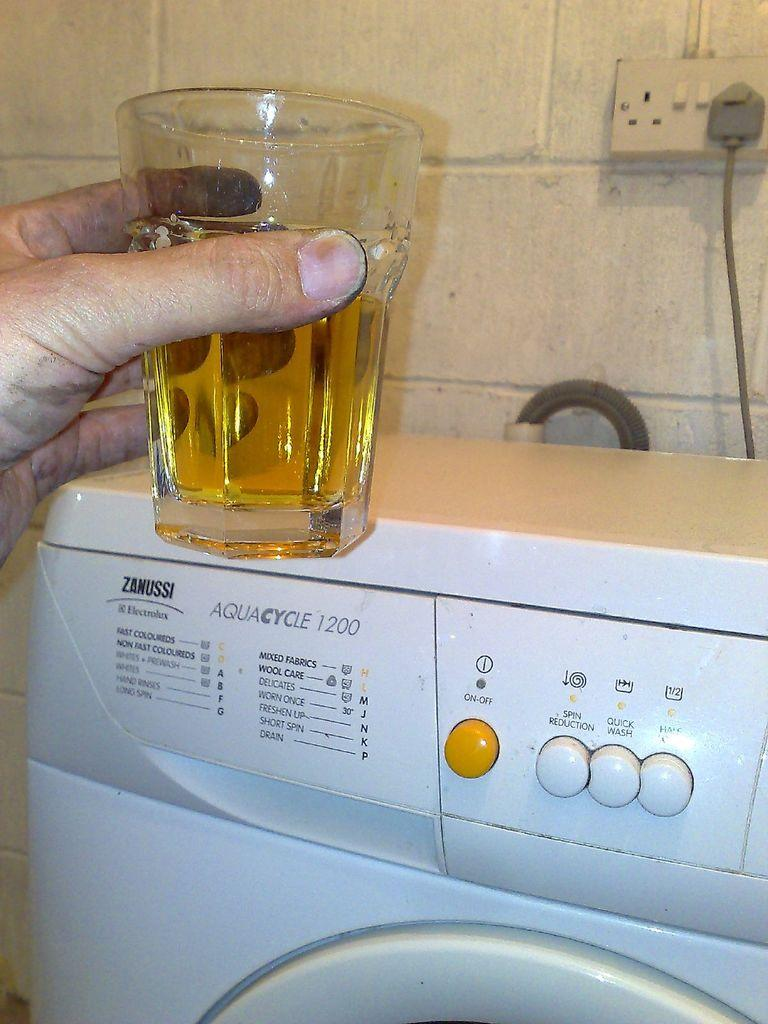Provide a one-sentence caption for the provided image. A person holds a glass with liquid in it above a Zanussi washing machine. 